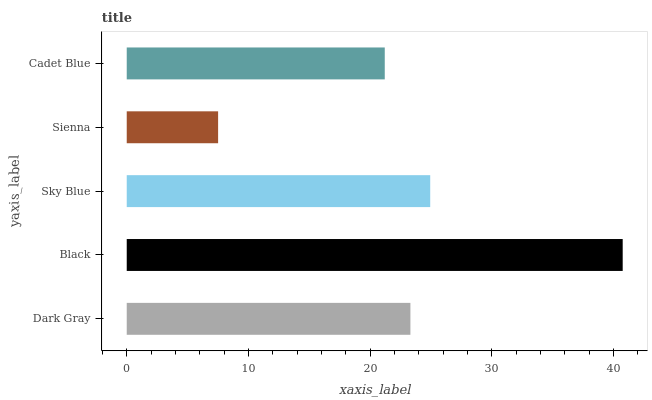Is Sienna the minimum?
Answer yes or no. Yes. Is Black the maximum?
Answer yes or no. Yes. Is Sky Blue the minimum?
Answer yes or no. No. Is Sky Blue the maximum?
Answer yes or no. No. Is Black greater than Sky Blue?
Answer yes or no. Yes. Is Sky Blue less than Black?
Answer yes or no. Yes. Is Sky Blue greater than Black?
Answer yes or no. No. Is Black less than Sky Blue?
Answer yes or no. No. Is Dark Gray the high median?
Answer yes or no. Yes. Is Dark Gray the low median?
Answer yes or no. Yes. Is Black the high median?
Answer yes or no. No. Is Sky Blue the low median?
Answer yes or no. No. 